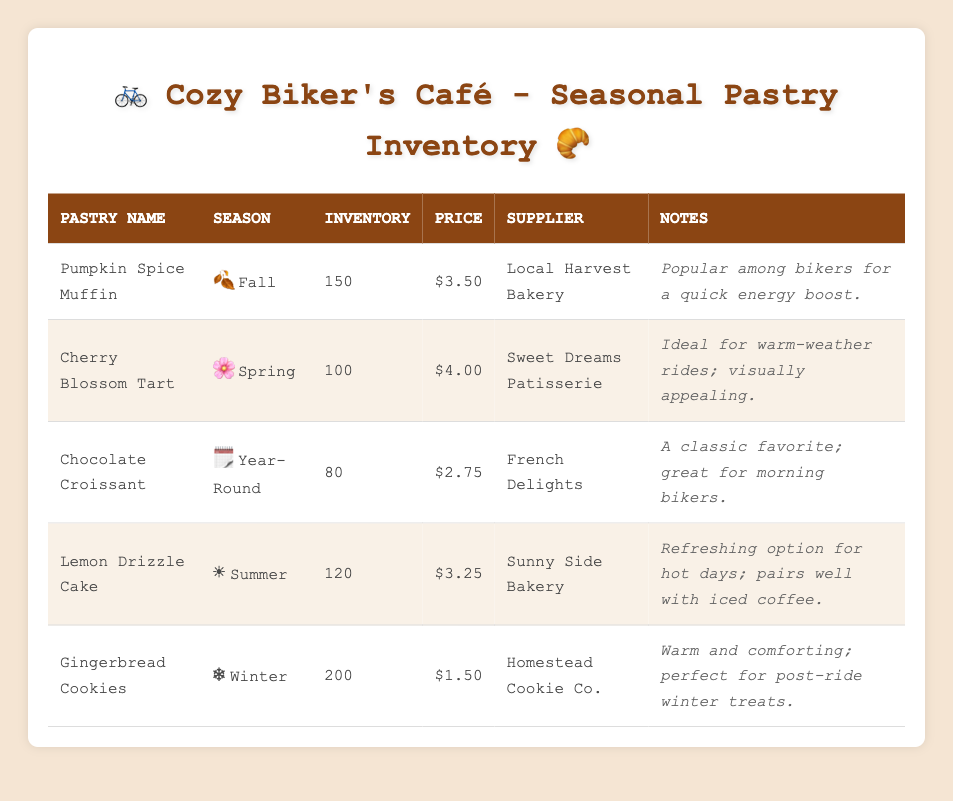What is the price of a Pumpkin Spice Muffin? The table shows that the price per unit of a Pumpkin Spice Muffin is listed directly under the Price column. Looking at the row for Pumpkin Spice Muffin, the value is $3.50.
Answer: $3.50 How many Lemon Drizzle Cakes are in inventory? To find the inventory count, look at the row for Lemon Drizzle Cake in the Inventory column. It shows an inventory count of 120, which answers the question directly.
Answer: 120 Which pastry has the highest inventory? The inventory counts for each pastry can be compared: Pumpkin Spice Muffin (150), Cherry Blossom Tart (100), Chocolate Croissant (80), Lemon Drizzle Cake (120), and Gingerbread Cookies (200). The Gingerbread Cookies have the highest count at 200.
Answer: Gingerbread Cookies Is the Cherry Blossom Tart available year-round? The table notes that Cherry Blossom Tart is categorized under the Spring season. Since it is not marked as year-round, this means it is not available throughout the entire year. Therefore, the answer is no.
Answer: No What is the average price of all pastries in inventory? First, add the prices of all pastries: $3.50 (Pumpkin Spice Muffin) + $4.00 (Cherry Blossom Tart) + $2.75 (Chocolate Croissant) + $3.25 (Lemon Drizzle Cake) + $1.50 (Gingerbread Cookies) = $15.00. Then divide by the total number of pastries (5) to find the average: $15.00/5 = $3.00.
Answer: $3.00 How many pastries have seasonal notes mentioning bikers? Looking at the notes, the Pumpkin Spice Muffin ("Popular among bikers for a quick energy boost") and the Chocolate Croissant ("great for morning bikers") both mention bikers. Thus, there are 2 pastries with such notes.
Answer: 2 Which supplier provides the most expensive pastry? Comparing the prices, the Cherry Blossom Tart at $4.00 is the most expensive pastry in the table. The supplier for this pastry is Sweet Dreams Patisserie, which answers the question.
Answer: Sweet Dreams Patisserie What is the total inventory count for pastries available in Summer and Winter? The Lemon Drizzle Cake is the only pastry specifically available in Summer (120) and Gingerbread Cookies are the only ones available in Winter (200). Therefore, performing the addition gives: 120 + 200 = 320 for pastries available in those seasons.
Answer: 320 How many pastries are sourced from Local Harvest Bakery? The table indicates that the only pastry supplied by Local Harvest Bakery is the Pumpkin Spice Muffin. Thus, there is a total of 1 pastry from that supplier.
Answer: 1 